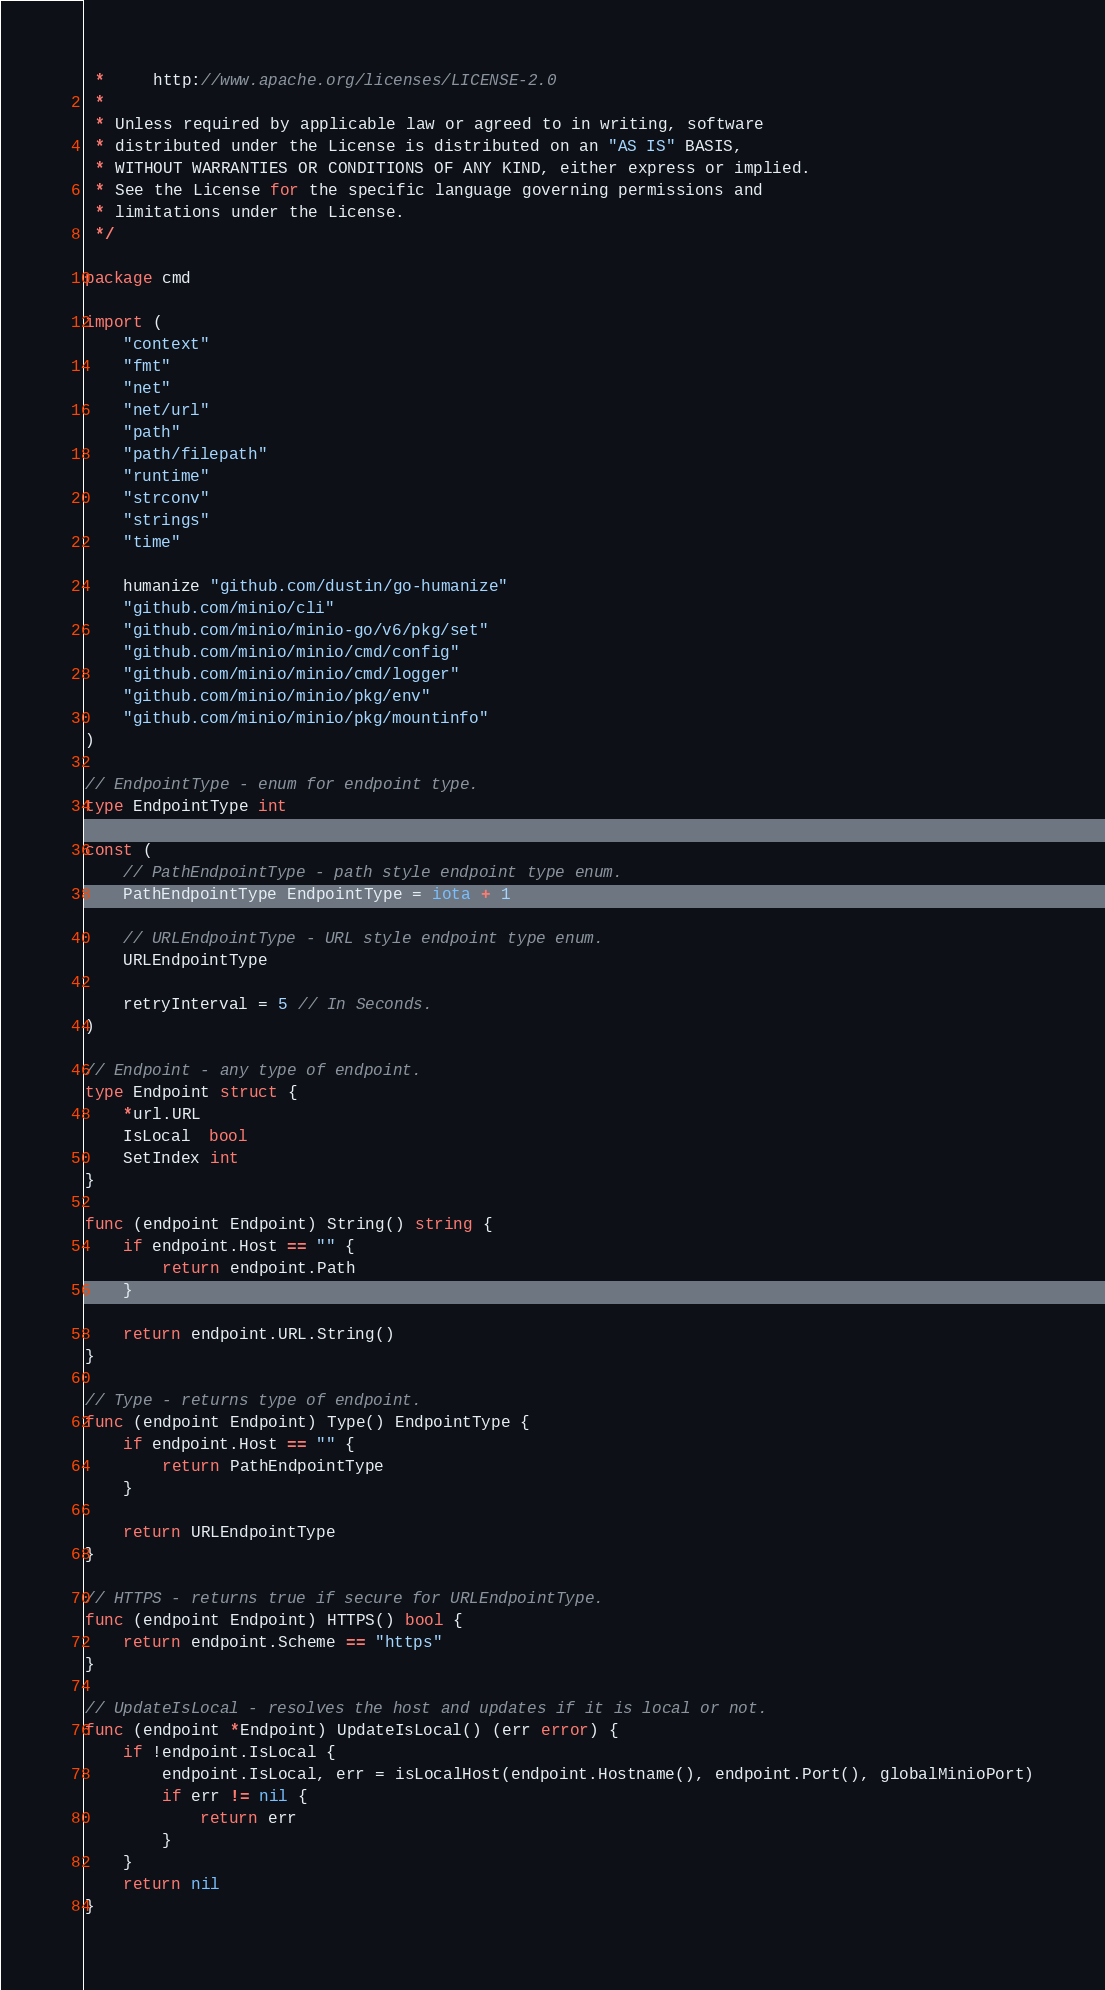Convert code to text. <code><loc_0><loc_0><loc_500><loc_500><_Go_> *     http://www.apache.org/licenses/LICENSE-2.0
 *
 * Unless required by applicable law or agreed to in writing, software
 * distributed under the License is distributed on an "AS IS" BASIS,
 * WITHOUT WARRANTIES OR CONDITIONS OF ANY KIND, either express or implied.
 * See the License for the specific language governing permissions and
 * limitations under the License.
 */

package cmd

import (
	"context"
	"fmt"
	"net"
	"net/url"
	"path"
	"path/filepath"
	"runtime"
	"strconv"
	"strings"
	"time"

	humanize "github.com/dustin/go-humanize"
	"github.com/minio/cli"
	"github.com/minio/minio-go/v6/pkg/set"
	"github.com/minio/minio/cmd/config"
	"github.com/minio/minio/cmd/logger"
	"github.com/minio/minio/pkg/env"
	"github.com/minio/minio/pkg/mountinfo"
)

// EndpointType - enum for endpoint type.
type EndpointType int

const (
	// PathEndpointType - path style endpoint type enum.
	PathEndpointType EndpointType = iota + 1

	// URLEndpointType - URL style endpoint type enum.
	URLEndpointType

	retryInterval = 5 // In Seconds.
)

// Endpoint - any type of endpoint.
type Endpoint struct {
	*url.URL
	IsLocal  bool
	SetIndex int
}

func (endpoint Endpoint) String() string {
	if endpoint.Host == "" {
		return endpoint.Path
	}

	return endpoint.URL.String()
}

// Type - returns type of endpoint.
func (endpoint Endpoint) Type() EndpointType {
	if endpoint.Host == "" {
		return PathEndpointType
	}

	return URLEndpointType
}

// HTTPS - returns true if secure for URLEndpointType.
func (endpoint Endpoint) HTTPS() bool {
	return endpoint.Scheme == "https"
}

// UpdateIsLocal - resolves the host and updates if it is local or not.
func (endpoint *Endpoint) UpdateIsLocal() (err error) {
	if !endpoint.IsLocal {
		endpoint.IsLocal, err = isLocalHost(endpoint.Hostname(), endpoint.Port(), globalMinioPort)
		if err != nil {
			return err
		}
	}
	return nil
}
</code> 